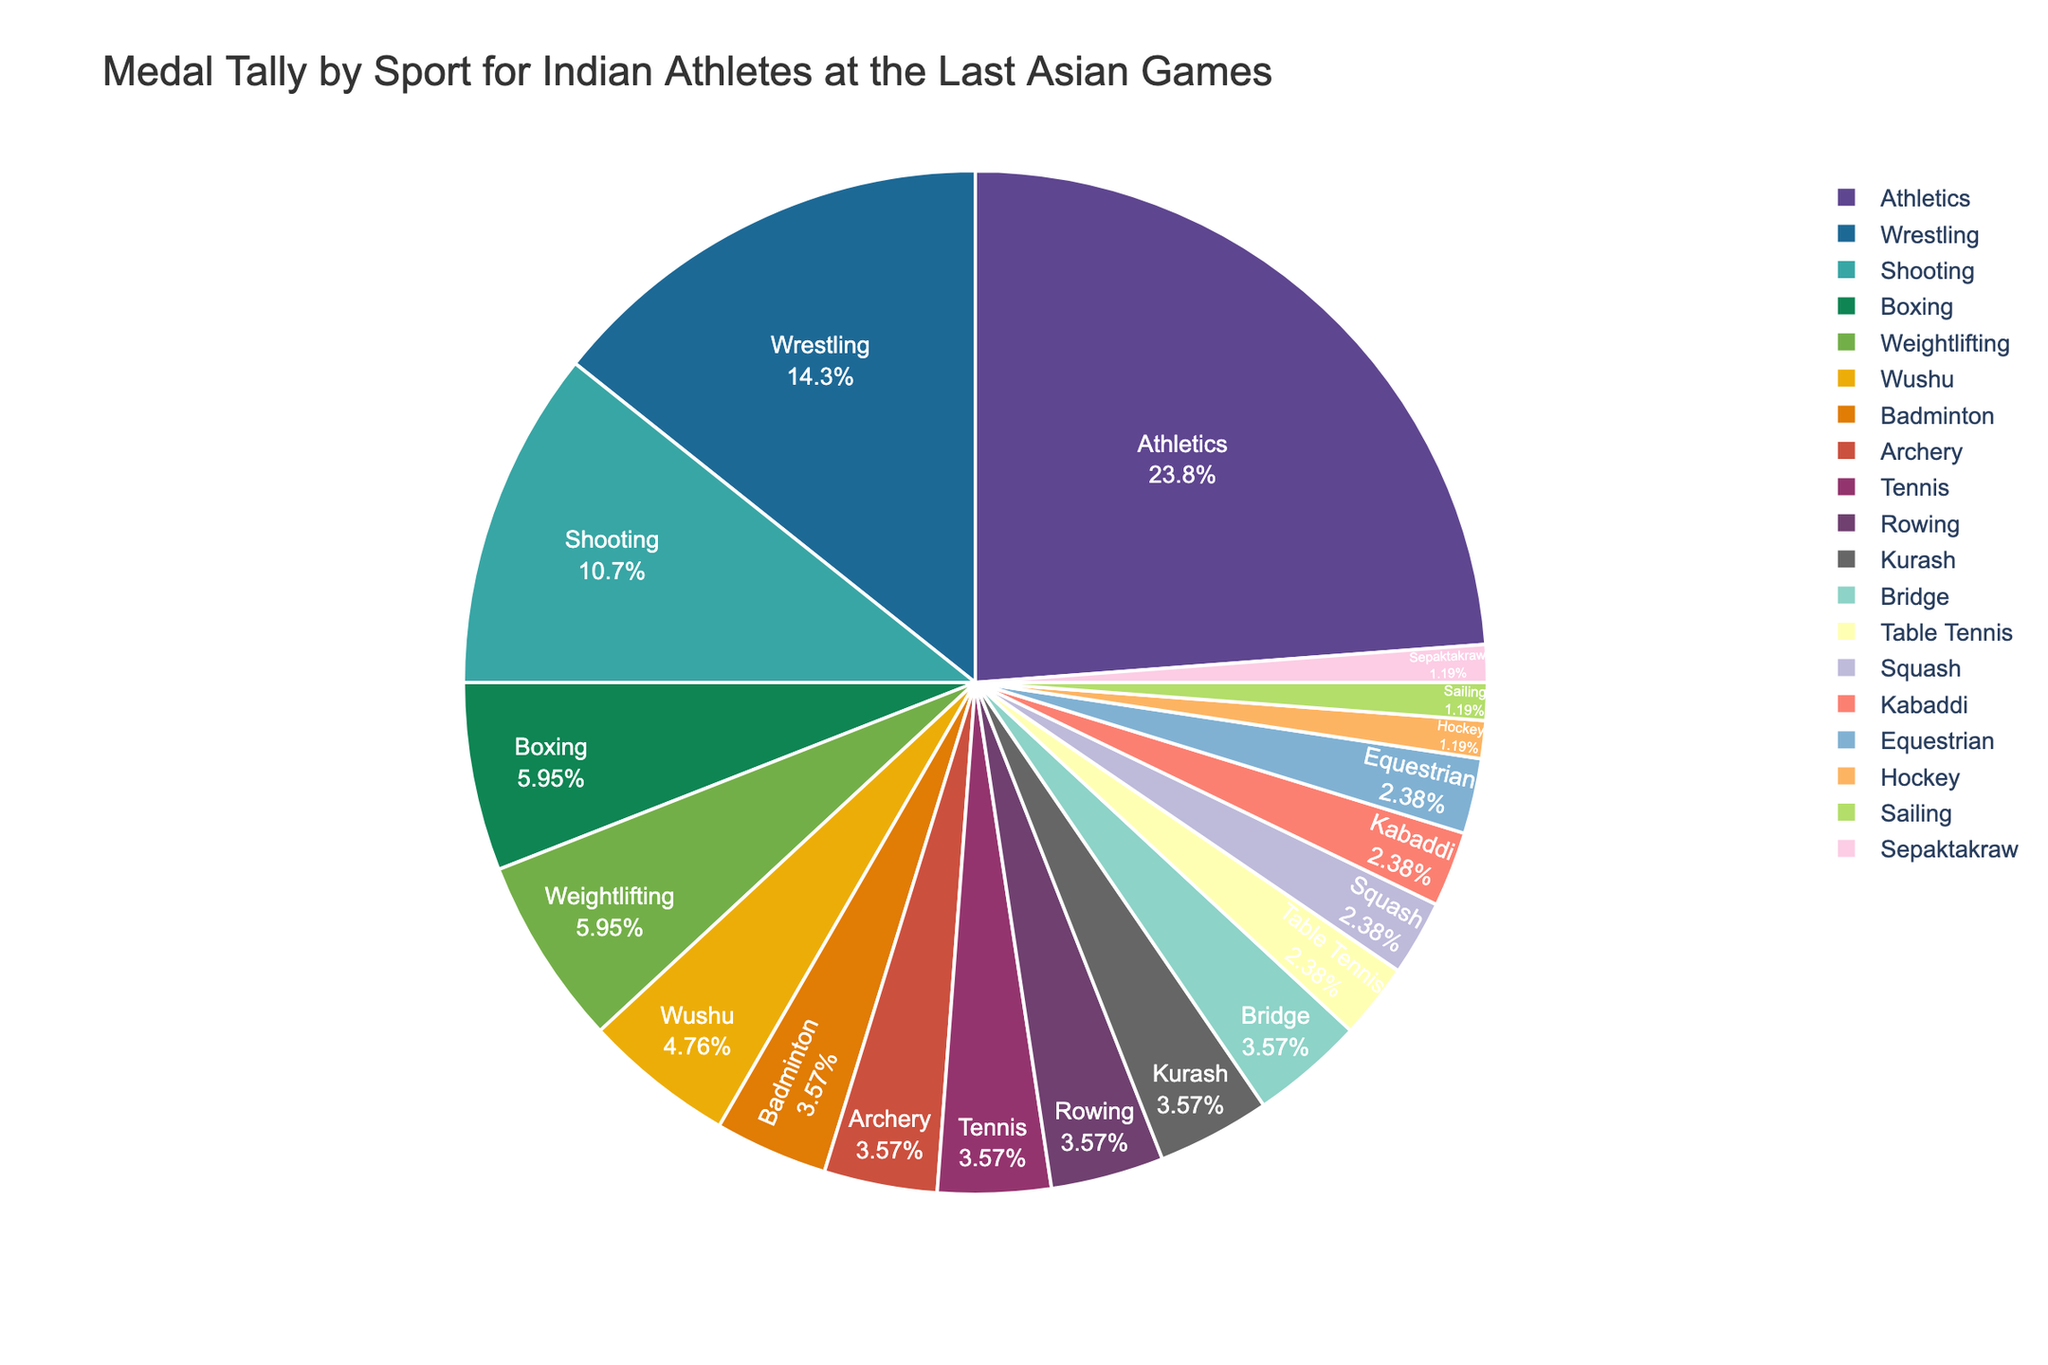Which sport contributed the most to the medal tally? By looking at the pie chart, identify the sport sector with the largest slice. Athletics has the highest share, indicating it contributed the most medals.
Answer: Athletics How many more medals did Athletics win compared to Shooting? Athletics won 20 medals while Shooting won 9. The difference is calculated by subtracting the number of medals in Shooting from those in Athletics: 20 - 9.
Answer: 11 Which is the least represented sport in terms of medals won? The smallest slice in the pie chart represents the sport with the least number of medals. Both Hockey, Sailing, and Sepaktakraw have the smallest slice, each indicating they won only 1 medal.
Answer: Hockey, Sailing, Sepaktakraw What percentage of the total medals did Wrestling win? Find the slice labeled Wrestling and note the percentage displayed inside it.
Answer: 12.37% Are there more medals won in Table Tennis or Equestrian? Compare the size of the slices for Table Tennis and Equestrian. Since they seem equal and each won 2 medals according to the data, they are even.
Answer: Equal What's the total number of medals won in Archery, Badminton, and Table Tennis combined? Sum the medals won in each sport: Archery (3) + Badminton (3) + Table Tennis (2).
Answer: 8 Which sport has a larger share of medals: Boxing or Weightlifting? Compare the sizes of the slices for Boxing and Weightlifting. Weightlifting’s slice is larger, indicating it has more medals.
Answer: Weightlifting What visual attributes differentiate the largest and smallest sectors in the pie chart? The largest sector (Athletics) is visually larger in area with a clear label and percentage, while the smallest sectors (Hockey, Sailing, Sepaktakraw) are narrow and small in comparison.
Answer: Size How does the medal count in Wushu compare to that in Bridge? Both sports have the same size slice if they have the same medal count. The data shows both Wushu and Bridge have 3 medals each.
Answer: Same Which sport sector uses vibrant or distinct colors to stand out in the pie chart? Identify the sectors shaded with more vibrant colors, like those with strong hues, which tend to draw attention. The Athletics sector, being the largest, might also use a distinct color.
Answer: Athletics (largest sector) 